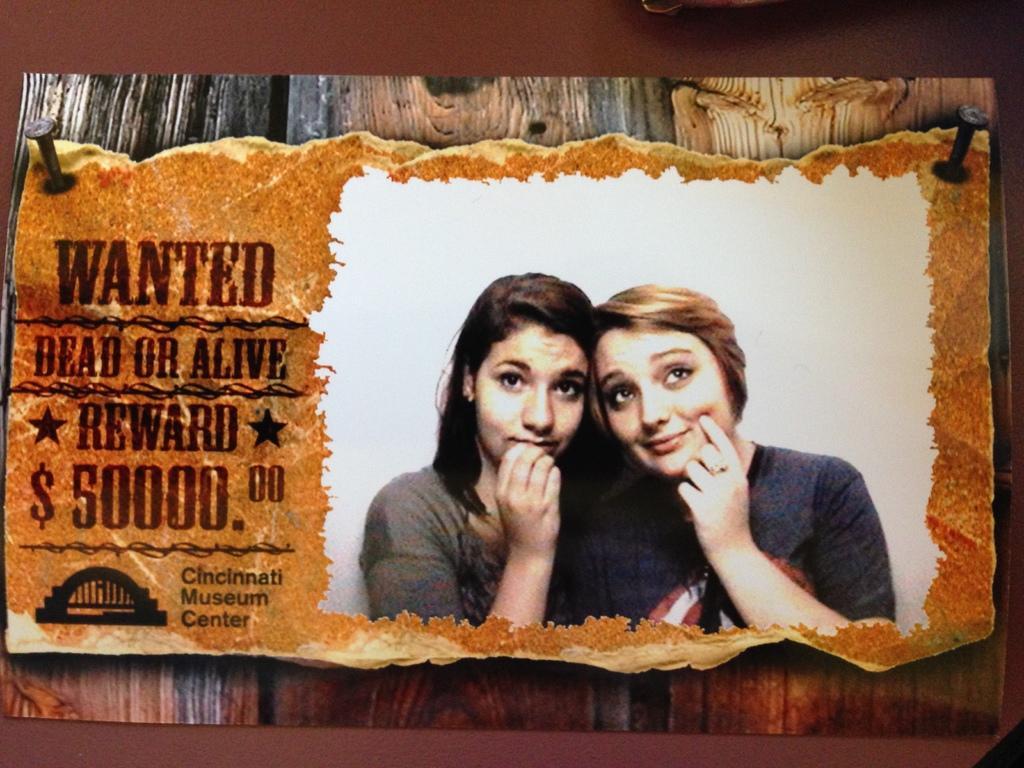How would you summarize this image in a sentence or two? This image is taken indoors. In this image there is a poster with images of two women and there is a text on it. In the background there is a wall. 